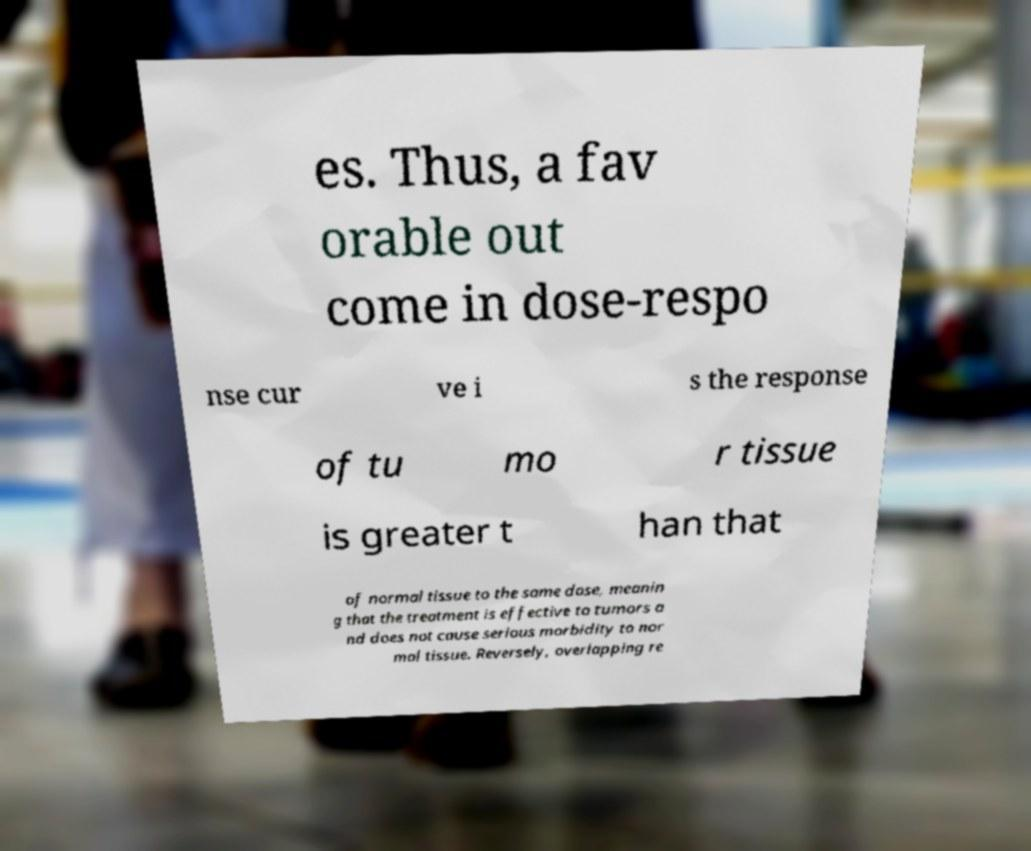For documentation purposes, I need the text within this image transcribed. Could you provide that? es. Thus, a fav orable out come in dose-respo nse cur ve i s the response of tu mo r tissue is greater t han that of normal tissue to the same dose, meanin g that the treatment is effective to tumors a nd does not cause serious morbidity to nor mal tissue. Reversely, overlapping re 